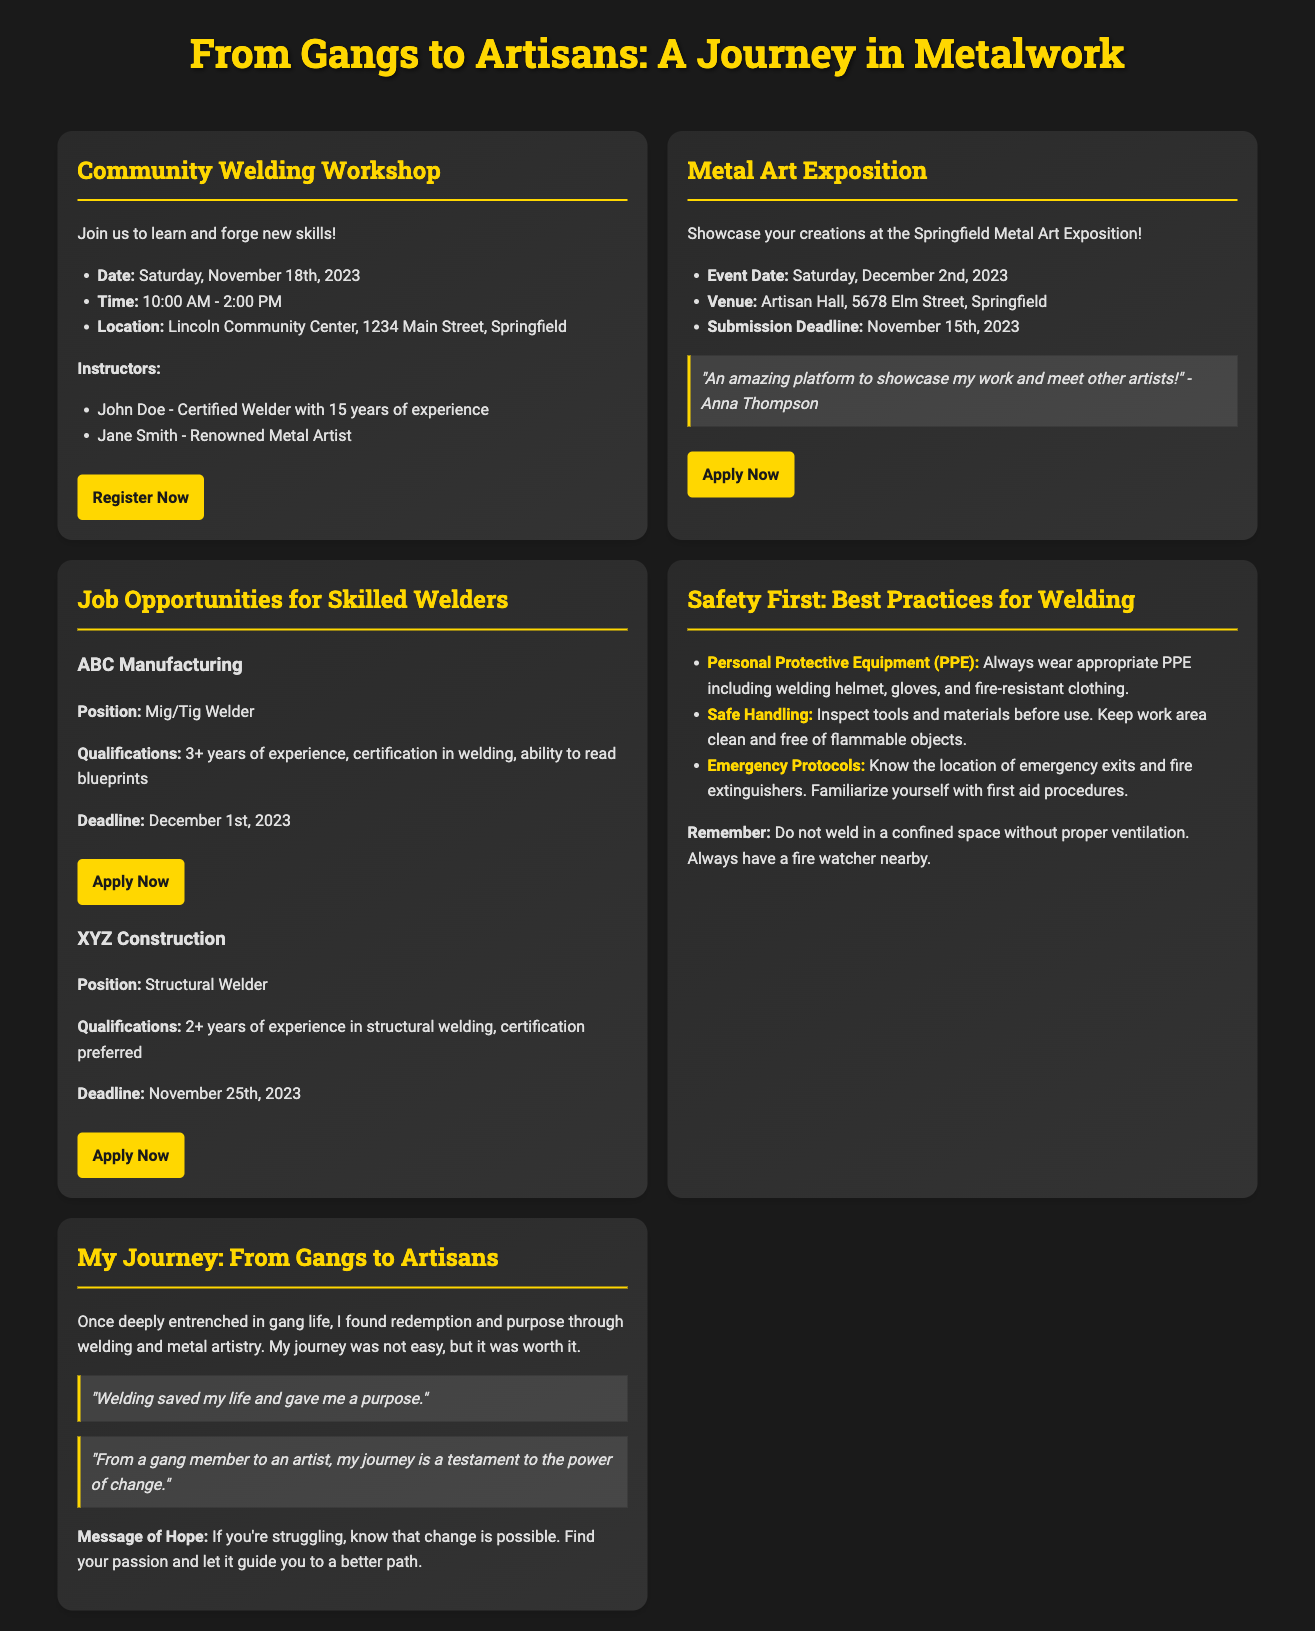What is the date of the Community Welding Workshop? The date of the workshop is specified in the document as Saturday, November 18th, 2023.
Answer: Saturday, November 18th, 2023 Who is one of the instructors for the welding workshop? The document lists instructors, including John Doe, who is a certified welder with 15 years of experience.
Answer: John Doe What is the submission deadline for the Metal Art Exposition? The deadline is provided in the flyer as November 15th, 2023.
Answer: November 15th, 2023 What type of welder is ABC Manufacturing hiring for? The job flyer specifically states they are looking for a Mig/Tig Welder.
Answer: Mig/Tig Welder What is a recommended piece of personal protective equipment for welding? The safety flyer highlights the importance of wearing a welding helmet as part of PPE.
Answer: Welding helmet What is the venue for the Metal Art Exposition? The document provides the information that the venue is Artisan Hall, 5678 Elm Street, Springfield.
Answer: Artisan Hall, 5678 Elm Street, Springfield What motivating message is shared in the personal story flyer? The personal story flyer contains a message of hope indicating that change is possible and to find your passion.
Answer: Change is possible How many years of experience are required for the Structural Welder position? The flyer states that XYZ Construction requires 2+ years of experience in structural welding.
Answer: 2+ years What event occurs on Saturday, December 2nd, 2023? The document mentions that the Metal Art Exposition will take place on this date.
Answer: Metal Art Exposition 